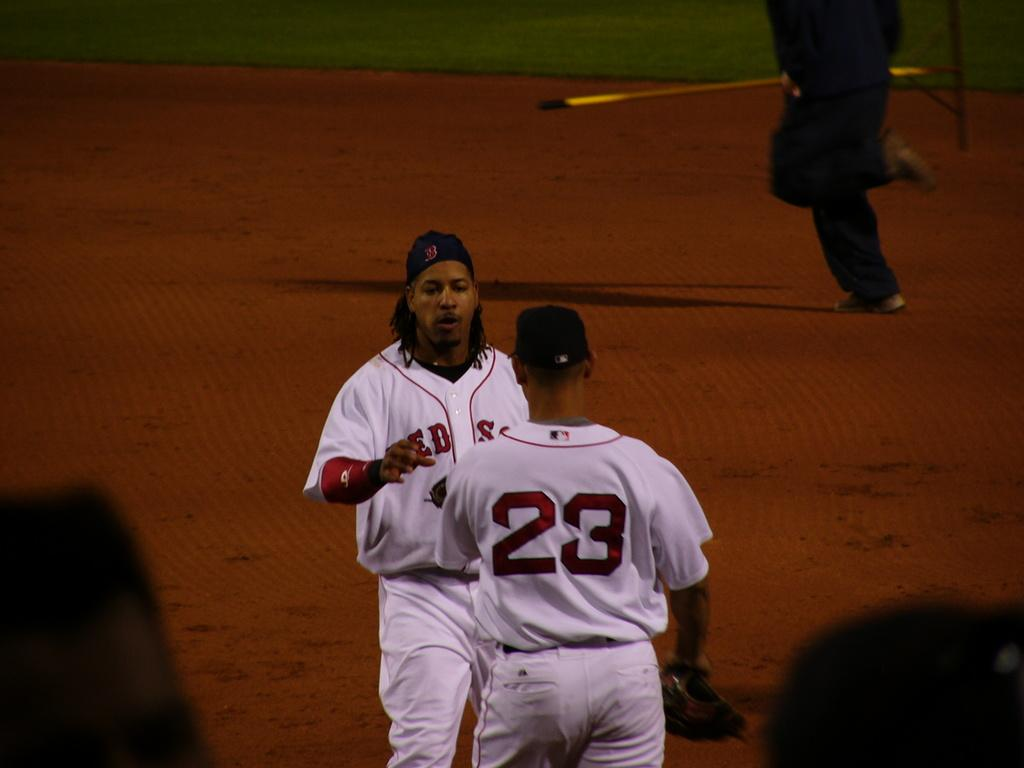<image>
Share a concise interpretation of the image provided. Two basball players with the Boston Red Sox are talking on the field. 